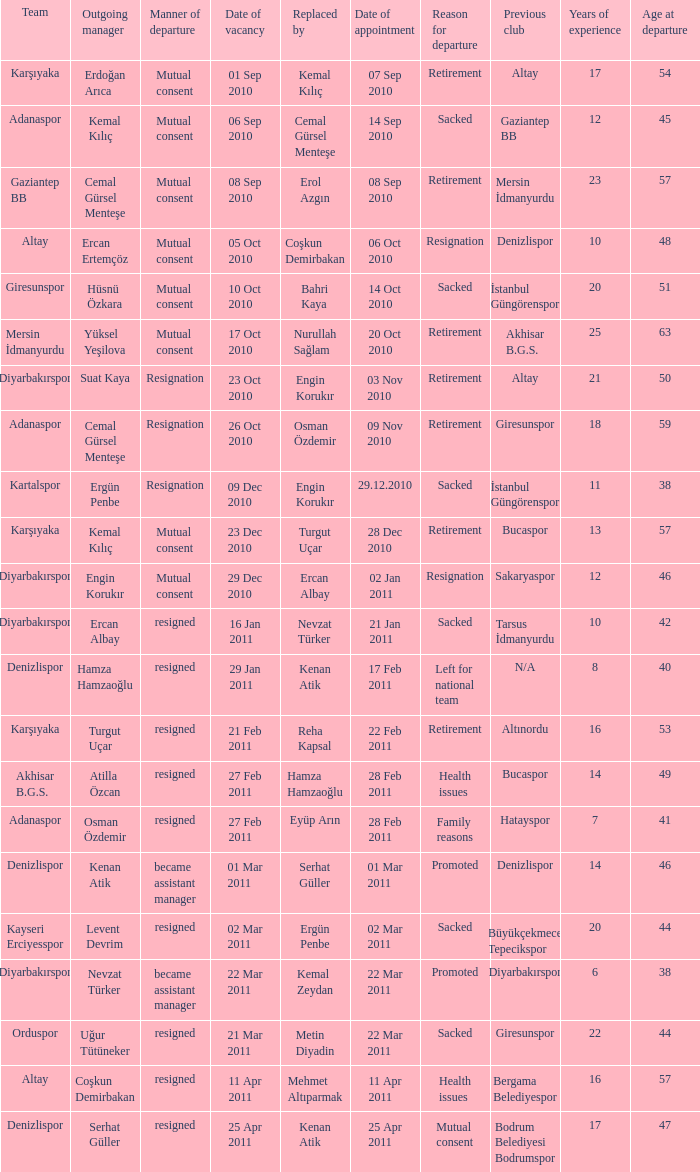Who replaced the outgoing manager Hüsnü Özkara?  Bahri Kaya. 